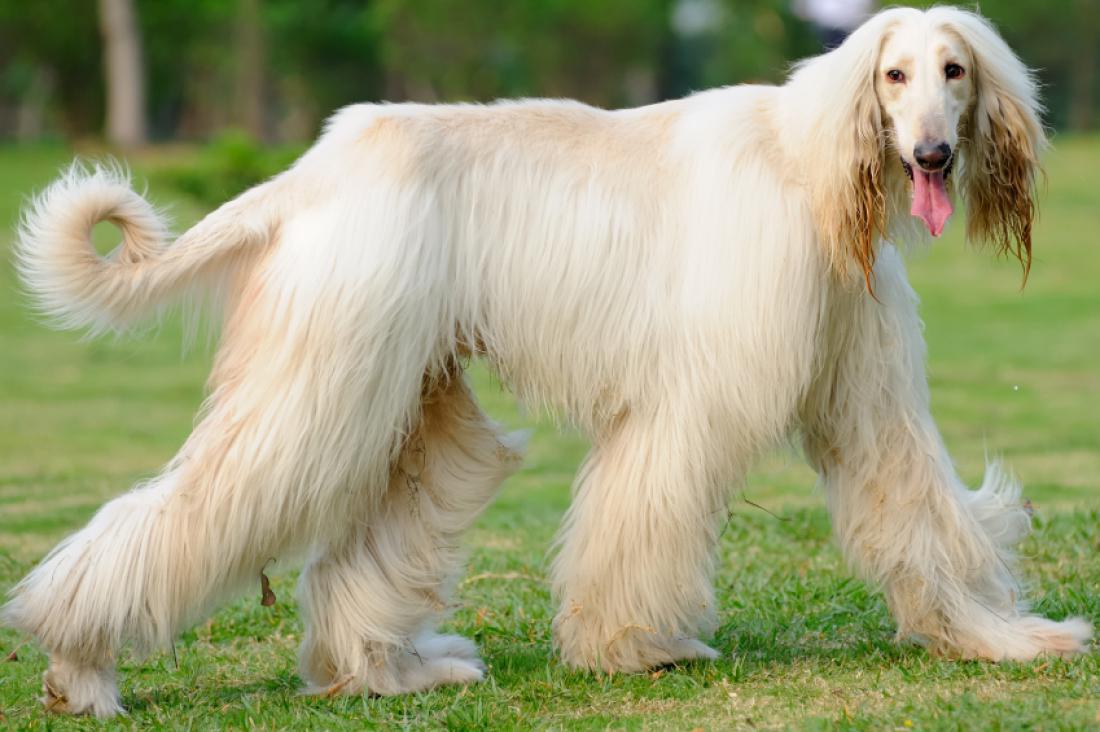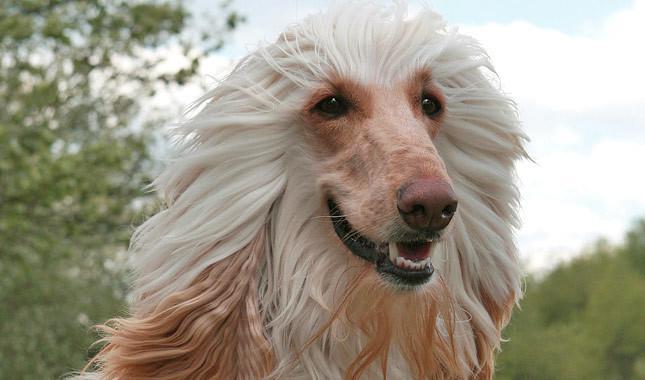The first image is the image on the left, the second image is the image on the right. Evaluate the accuracy of this statement regarding the images: "One image shows a hound with windswept hair on its head.". Is it true? Answer yes or no. Yes. 